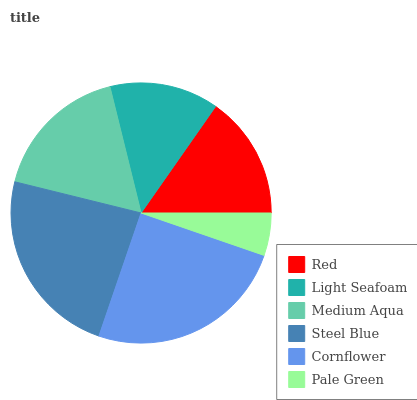Is Pale Green the minimum?
Answer yes or no. Yes. Is Cornflower the maximum?
Answer yes or no. Yes. Is Light Seafoam the minimum?
Answer yes or no. No. Is Light Seafoam the maximum?
Answer yes or no. No. Is Red greater than Light Seafoam?
Answer yes or no. Yes. Is Light Seafoam less than Red?
Answer yes or no. Yes. Is Light Seafoam greater than Red?
Answer yes or no. No. Is Red less than Light Seafoam?
Answer yes or no. No. Is Medium Aqua the high median?
Answer yes or no. Yes. Is Red the low median?
Answer yes or no. Yes. Is Light Seafoam the high median?
Answer yes or no. No. Is Pale Green the low median?
Answer yes or no. No. 